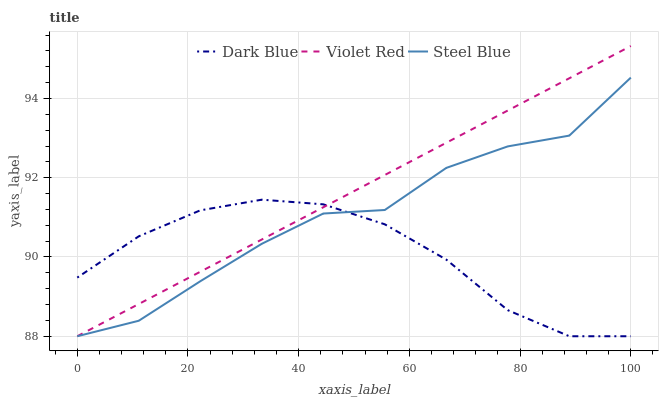Does Dark Blue have the minimum area under the curve?
Answer yes or no. Yes. Does Violet Red have the maximum area under the curve?
Answer yes or no. Yes. Does Steel Blue have the minimum area under the curve?
Answer yes or no. No. Does Steel Blue have the maximum area under the curve?
Answer yes or no. No. Is Violet Red the smoothest?
Answer yes or no. Yes. Is Steel Blue the roughest?
Answer yes or no. Yes. Is Steel Blue the smoothest?
Answer yes or no. No. Is Violet Red the roughest?
Answer yes or no. No. Does Dark Blue have the lowest value?
Answer yes or no. Yes. Does Violet Red have the highest value?
Answer yes or no. Yes. Does Steel Blue have the highest value?
Answer yes or no. No. Does Dark Blue intersect Steel Blue?
Answer yes or no. Yes. Is Dark Blue less than Steel Blue?
Answer yes or no. No. Is Dark Blue greater than Steel Blue?
Answer yes or no. No. 